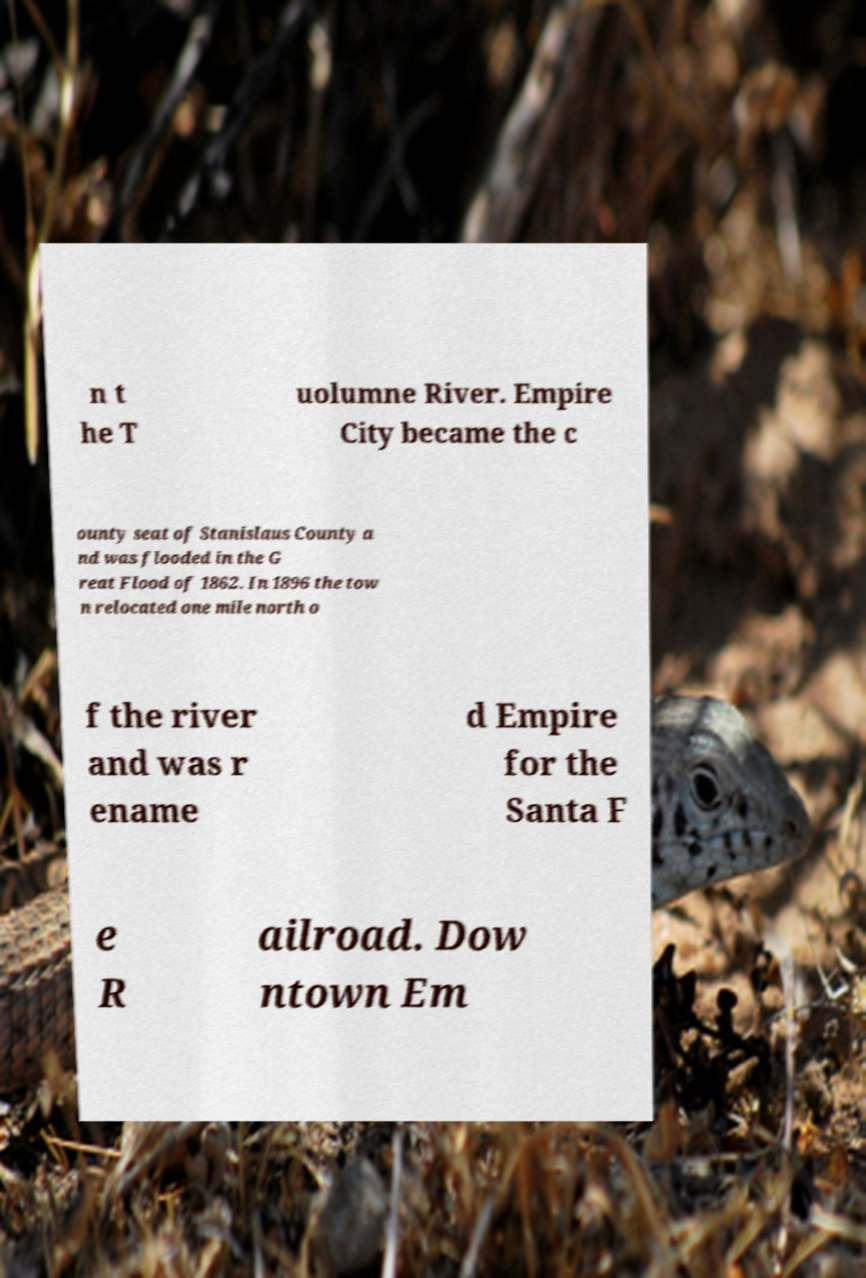I need the written content from this picture converted into text. Can you do that? n t he T uolumne River. Empire City became the c ounty seat of Stanislaus County a nd was flooded in the G reat Flood of 1862. In 1896 the tow n relocated one mile north o f the river and was r ename d Empire for the Santa F e R ailroad. Dow ntown Em 